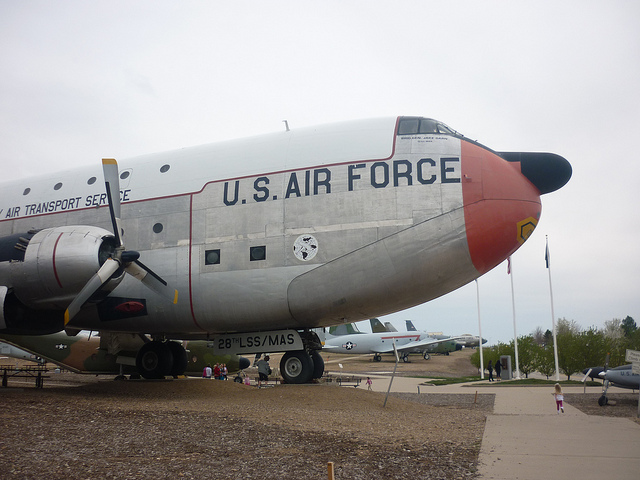<image>What airline is the airplane from? I am not sure about the airline of the airplane. It can be US Air Force or other military plane. What airline is the airplane from? It is unclear what airline the airplane is from. It is possible that it is from the US Air Force or it could be a civilian plane. 